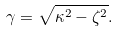Convert formula to latex. <formula><loc_0><loc_0><loc_500><loc_500>\gamma = \sqrt { \kappa ^ { 2 } - \zeta ^ { 2 } } .</formula> 